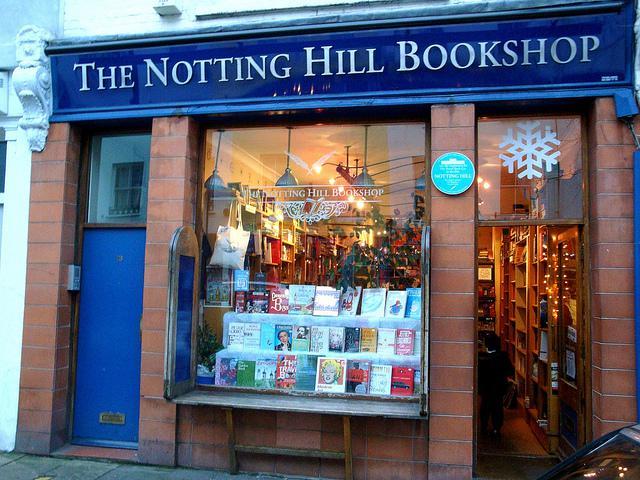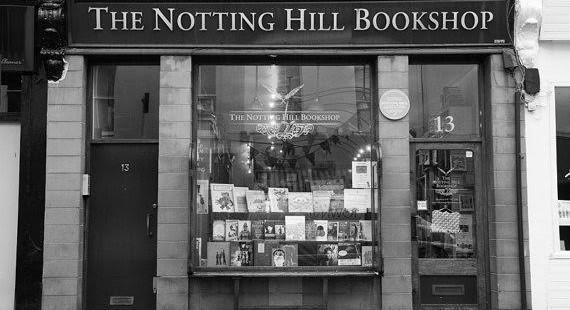The first image is the image on the left, the second image is the image on the right. Assess this claim about the two images: "Two images of the same brick bookshop with blue trim show a large window between two doorways, a person sitting on a window ledge in one image.". Correct or not? Answer yes or no. No. The first image is the image on the left, the second image is the image on the right. For the images shown, is this caption "There is a person sitting down on the ledge along the storefront window." true? Answer yes or no. No. 